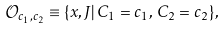Convert formula to latex. <formula><loc_0><loc_0><loc_500><loc_500>\mathcal { O } _ { c _ { 1 } , c _ { 2 } } \equiv \{ x , J | \, C _ { 1 } = c _ { 1 } , \, C _ { 2 } = c _ { 2 } \} ,</formula> 